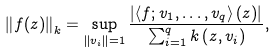Convert formula to latex. <formula><loc_0><loc_0><loc_500><loc_500>\left \| f ( z ) \right \| _ { k } = \sup _ { \left \| v _ { i } \right \| = 1 } \frac { \left | \left \langle f ; v _ { 1 } , \dots , v _ { q } \right \rangle ( z ) \right | } { \sum _ { i = 1 } ^ { q } k \left ( z , v _ { i } \right ) } ,</formula> 